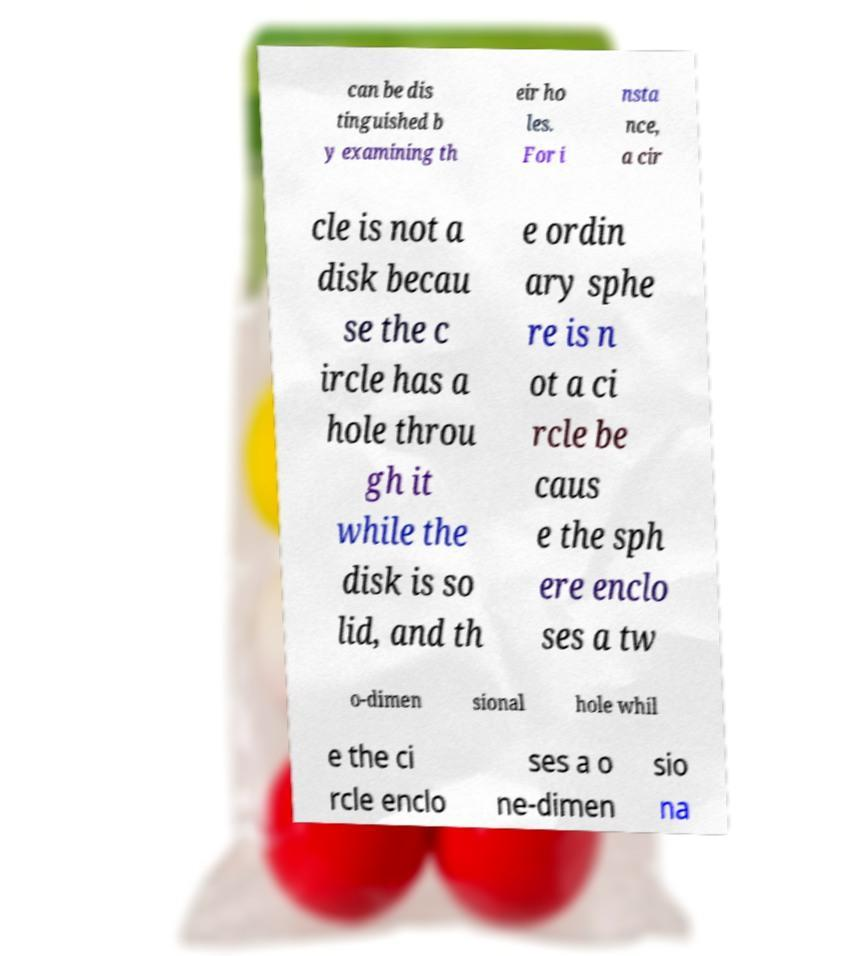Can you read and provide the text displayed in the image?This photo seems to have some interesting text. Can you extract and type it out for me? can be dis tinguished b y examining th eir ho les. For i nsta nce, a cir cle is not a disk becau se the c ircle has a hole throu gh it while the disk is so lid, and th e ordin ary sphe re is n ot a ci rcle be caus e the sph ere enclo ses a tw o-dimen sional hole whil e the ci rcle enclo ses a o ne-dimen sio na 